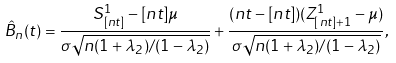Convert formula to latex. <formula><loc_0><loc_0><loc_500><loc_500>\hat { B } _ { n } ( t ) = \frac { S ^ { 1 } _ { [ n t ] } - [ n t ] \mu } { \sigma \sqrt { n ( 1 + \lambda _ { 2 } ) / ( 1 - \lambda _ { 2 } ) } } + \frac { ( n t - [ n t ] ) ( Z ^ { 1 } _ { [ n t ] + 1 } - \mu ) } { \sigma \sqrt { n ( 1 + \lambda _ { 2 } ) / ( 1 - \lambda _ { 2 } ) } } ,</formula> 